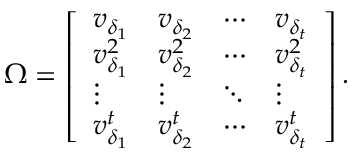<formula> <loc_0><loc_0><loc_500><loc_500>\Omega = \left [ \begin{array} { l l l l } { v _ { \delta _ { 1 } } } & { v _ { \delta _ { 2 } } } & { \cdots } & { v _ { \delta _ { t } } } \\ { v _ { \delta _ { 1 } } ^ { 2 } } & { v _ { \delta _ { 2 } } ^ { 2 } } & { \cdots } & { v _ { \delta _ { t } } ^ { 2 } } \\ { \vdots } & { \vdots } & { \ddots } & { \vdots } \\ { v _ { \delta _ { 1 } } ^ { t } } & { v _ { \delta _ { 2 } } ^ { t } } & { \cdots } & { v _ { \delta _ { t } } ^ { t } } \end{array} \right ] .</formula> 